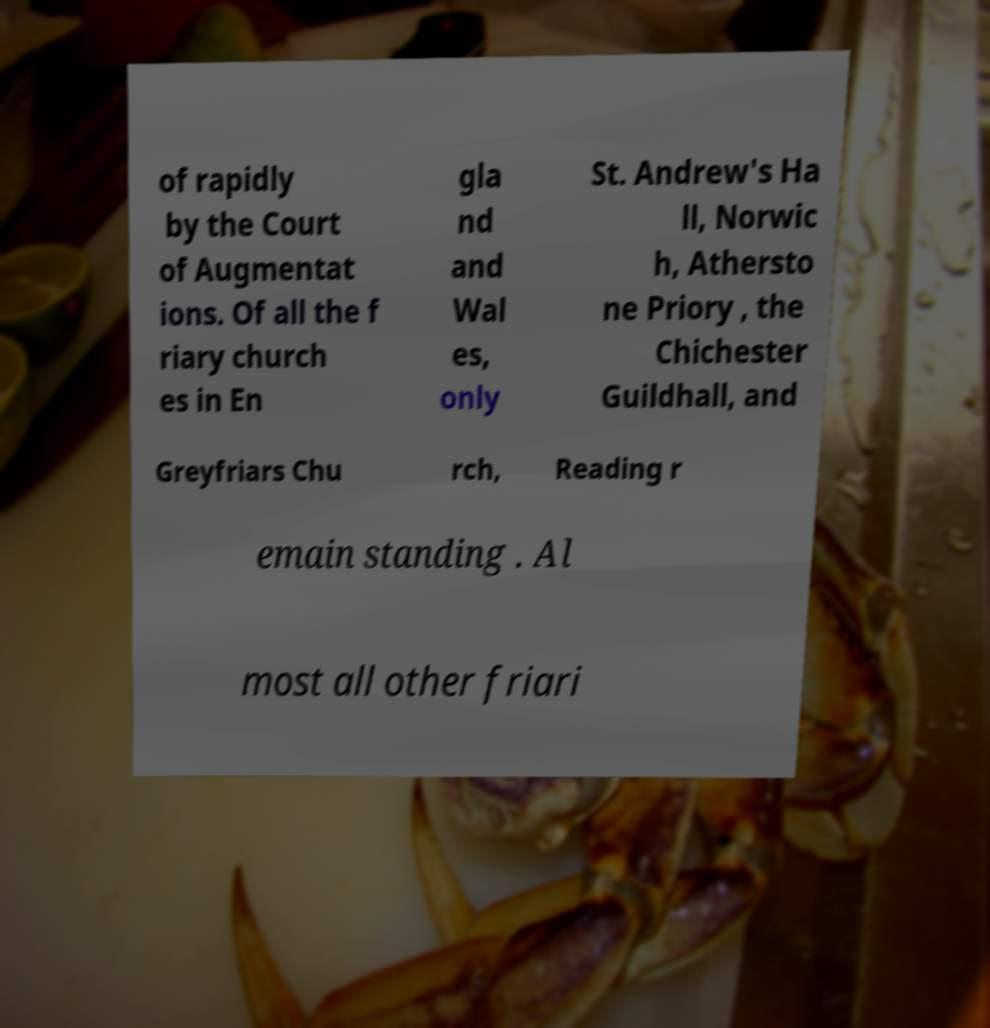For documentation purposes, I need the text within this image transcribed. Could you provide that? of rapidly by the Court of Augmentat ions. Of all the f riary church es in En gla nd and Wal es, only St. Andrew's Ha ll, Norwic h, Athersto ne Priory , the Chichester Guildhall, and Greyfriars Chu rch, Reading r emain standing . Al most all other friari 